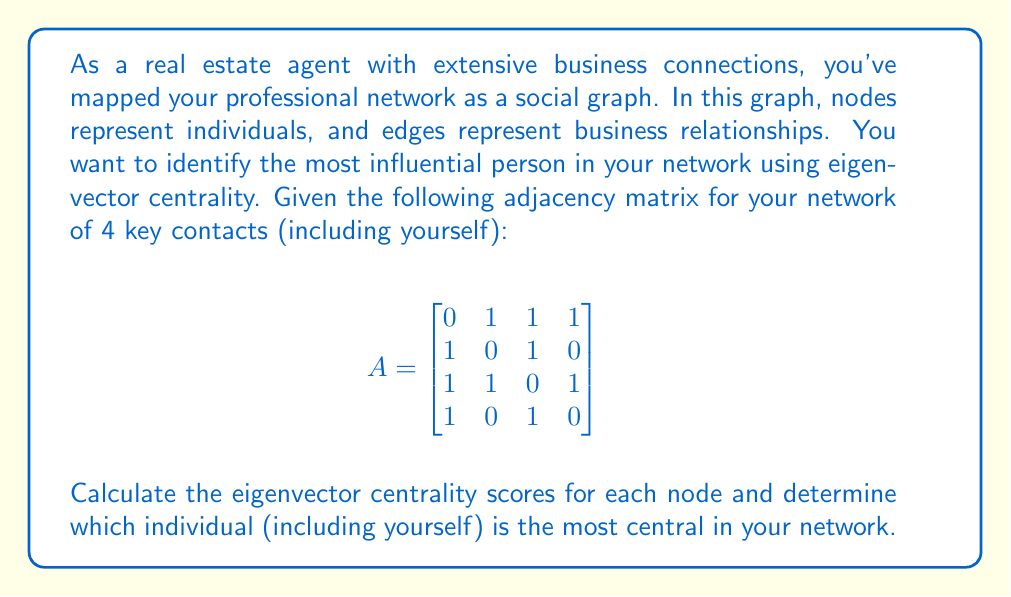Can you answer this question? To solve this problem, we'll follow these steps:

1) First, we need to find the eigenvalues and eigenvectors of the adjacency matrix A.

2) The eigenvector centrality scores are given by the elements of the eigenvector corresponding to the largest eigenvalue.

3) We'll use the power iteration method to find the dominant eigenvector:

   a) Start with an initial guess vector $\mathbf{x}_0 = [1, 1, 1, 1]^T$
   b) Iterate: $\mathbf{x}_{k+1} = \frac{A\mathbf{x}_k}{\|A\mathbf{x}_k\|}$
   c) Stop when the change between iterations is small

4) Let's perform a few iterations:

   Iteration 1:
   $$A\mathbf{x}_0 = [3, 2, 3, 2]^T$$
   $$\mathbf{x}_1 = \frac{[3, 2, 3, 2]^T}{\sqrt{3^2 + 2^2 + 3^2 + 2^2}} = [0.6, 0.4, 0.6, 0.4]^T$$

   Iteration 2:
   $$A\mathbf{x}_1 = [1.4, 1.2, 1.6, 1.0]^T$$
   $$\mathbf{x}_2 = \frac{[1.4, 1.2, 1.6, 1.0]^T}{\sqrt{1.4^2 + 1.2^2 + 1.6^2 + 1.0^2}} = [0.5164, 0.4426, 0.5901, 0.3688]^T$$

   Iteration 3:
   $$A\mathbf{x}_2 = [1.4015, 1.1065, 1.5279, 1.1065]^T$$
   $$\mathbf{x}_3 = \frac{[1.4015, 1.1065, 1.5279, 1.1065]^T}{\sqrt{1.4015^2 + 1.1065^2 + 1.5279^2 + 1.1065^2}} = [0.5140, 0.4058, 0.5603, 0.4058]^T$$

5) The vector is converging, so we'll stop here. The eigenvector centrality scores are approximately:

   Node 1: 0.5140
   Node 2: 0.4058
   Node 3: 0.5603
   Node 4: 0.4058

6) The highest score is 0.5603, corresponding to Node 3.
Answer: Node 3 has the highest eigenvector centrality score of approximately 0.5603, making it the most central node in the network. 